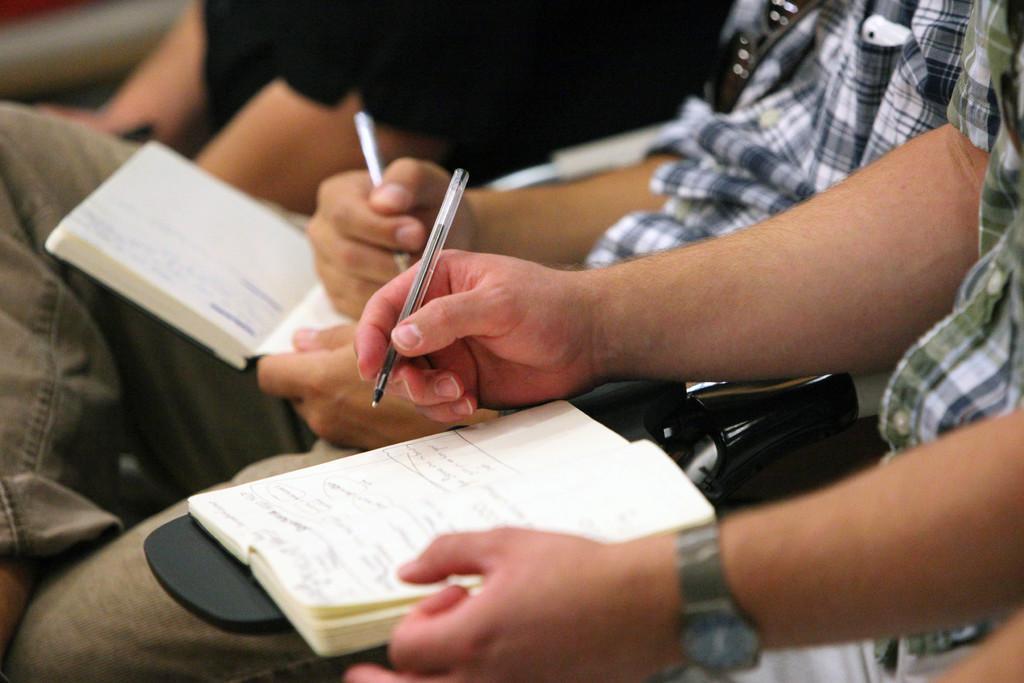Could you give a brief overview of what you see in this image? In this picture we can see two persons holding books and pens, among them to a man there is goggles and an object. At the top of the image, there is another person. 